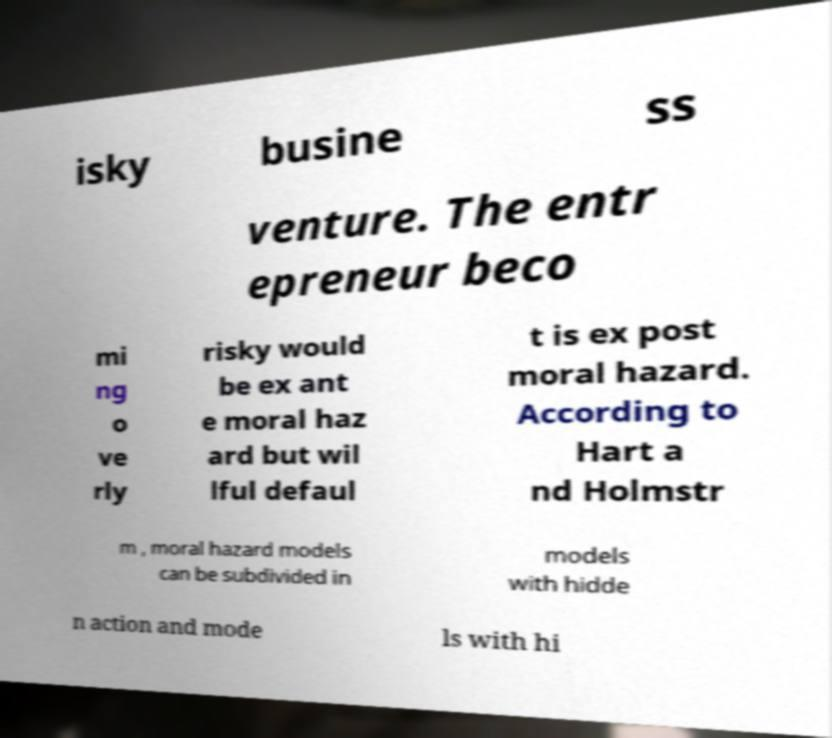I need the written content from this picture converted into text. Can you do that? isky busine ss venture. The entr epreneur beco mi ng o ve rly risky would be ex ant e moral haz ard but wil lful defaul t is ex post moral hazard. According to Hart a nd Holmstr m , moral hazard models can be subdivided in models with hidde n action and mode ls with hi 